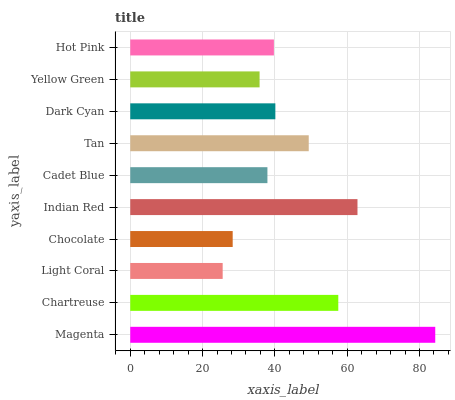Is Light Coral the minimum?
Answer yes or no. Yes. Is Magenta the maximum?
Answer yes or no. Yes. Is Chartreuse the minimum?
Answer yes or no. No. Is Chartreuse the maximum?
Answer yes or no. No. Is Magenta greater than Chartreuse?
Answer yes or no. Yes. Is Chartreuse less than Magenta?
Answer yes or no. Yes. Is Chartreuse greater than Magenta?
Answer yes or no. No. Is Magenta less than Chartreuse?
Answer yes or no. No. Is Dark Cyan the high median?
Answer yes or no. Yes. Is Hot Pink the low median?
Answer yes or no. Yes. Is Magenta the high median?
Answer yes or no. No. Is Cadet Blue the low median?
Answer yes or no. No. 